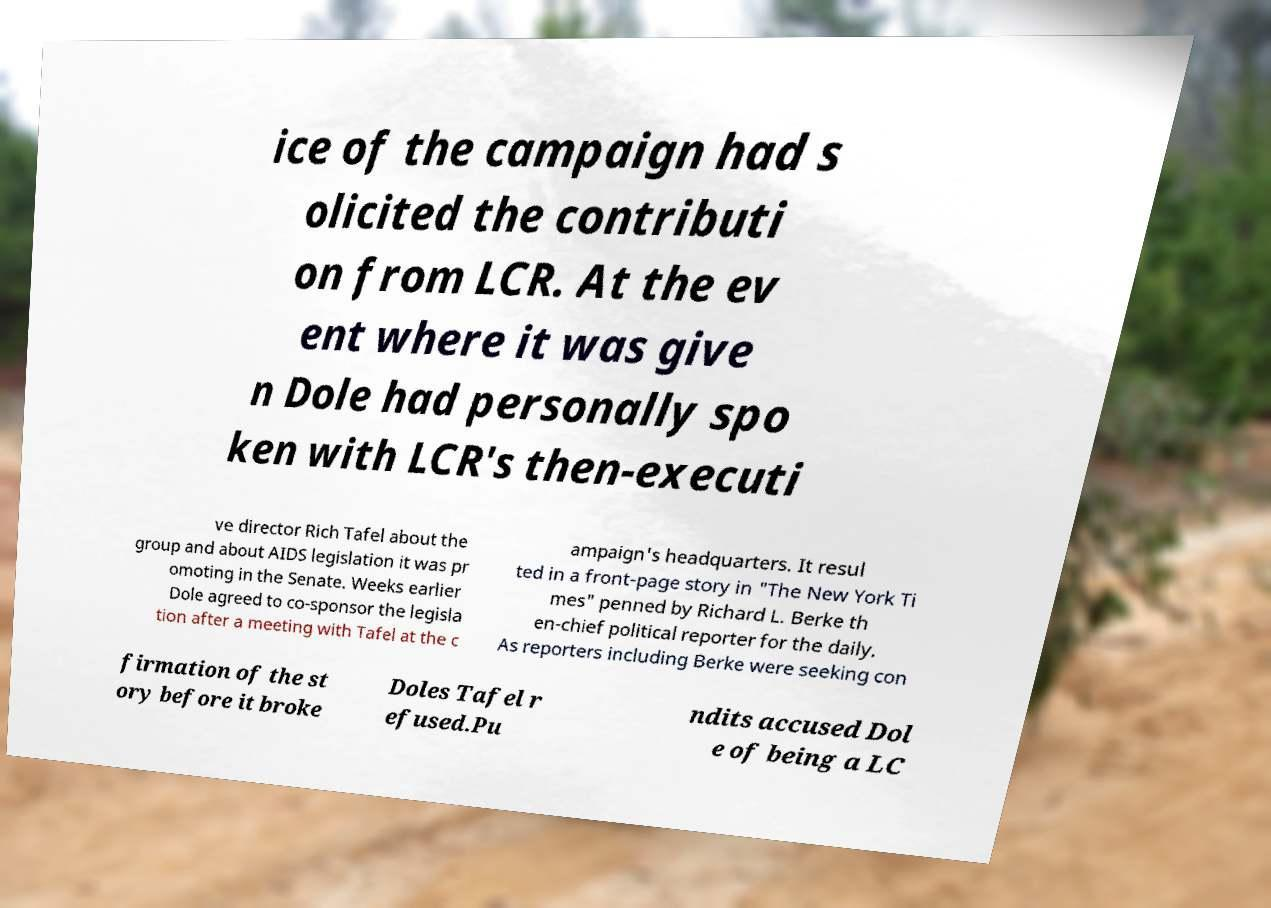Please read and relay the text visible in this image. What does it say? ice of the campaign had s olicited the contributi on from LCR. At the ev ent where it was give n Dole had personally spo ken with LCR's then-executi ve director Rich Tafel about the group and about AIDS legislation it was pr omoting in the Senate. Weeks earlier Dole agreed to co-sponsor the legisla tion after a meeting with Tafel at the c ampaign's headquarters. It resul ted in a front-page story in "The New York Ti mes" penned by Richard L. Berke th en-chief political reporter for the daily. As reporters including Berke were seeking con firmation of the st ory before it broke Doles Tafel r efused.Pu ndits accused Dol e of being a LC 